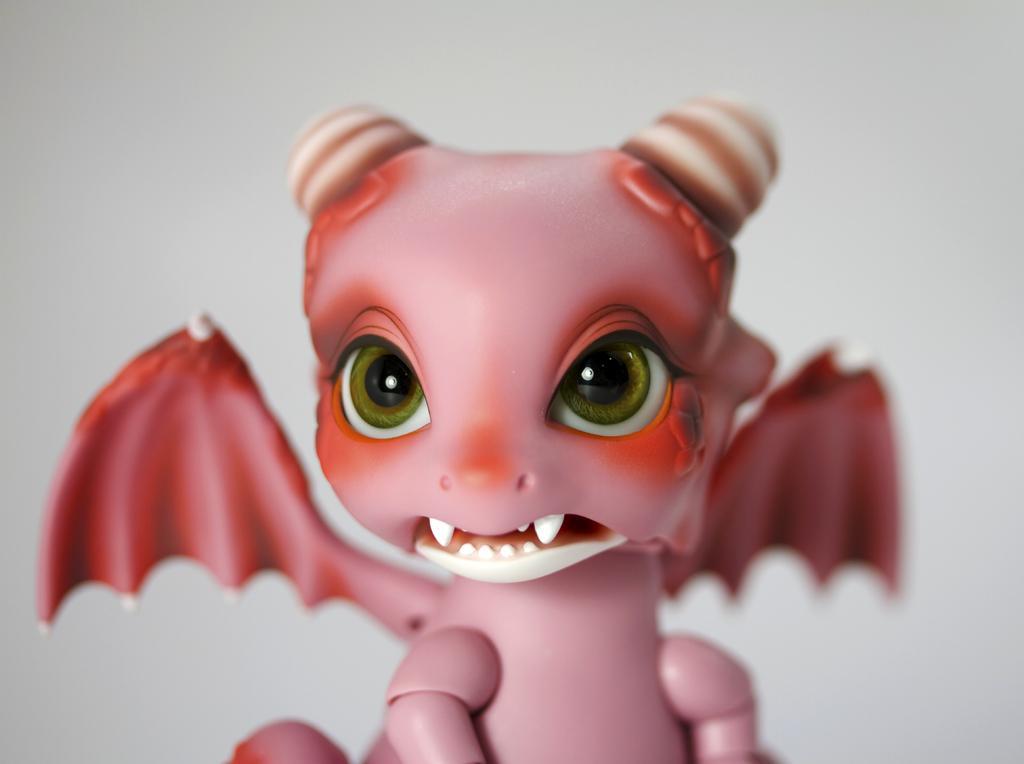Please provide a concise description of this image. In this image we can see a pink color toy with white color background. 